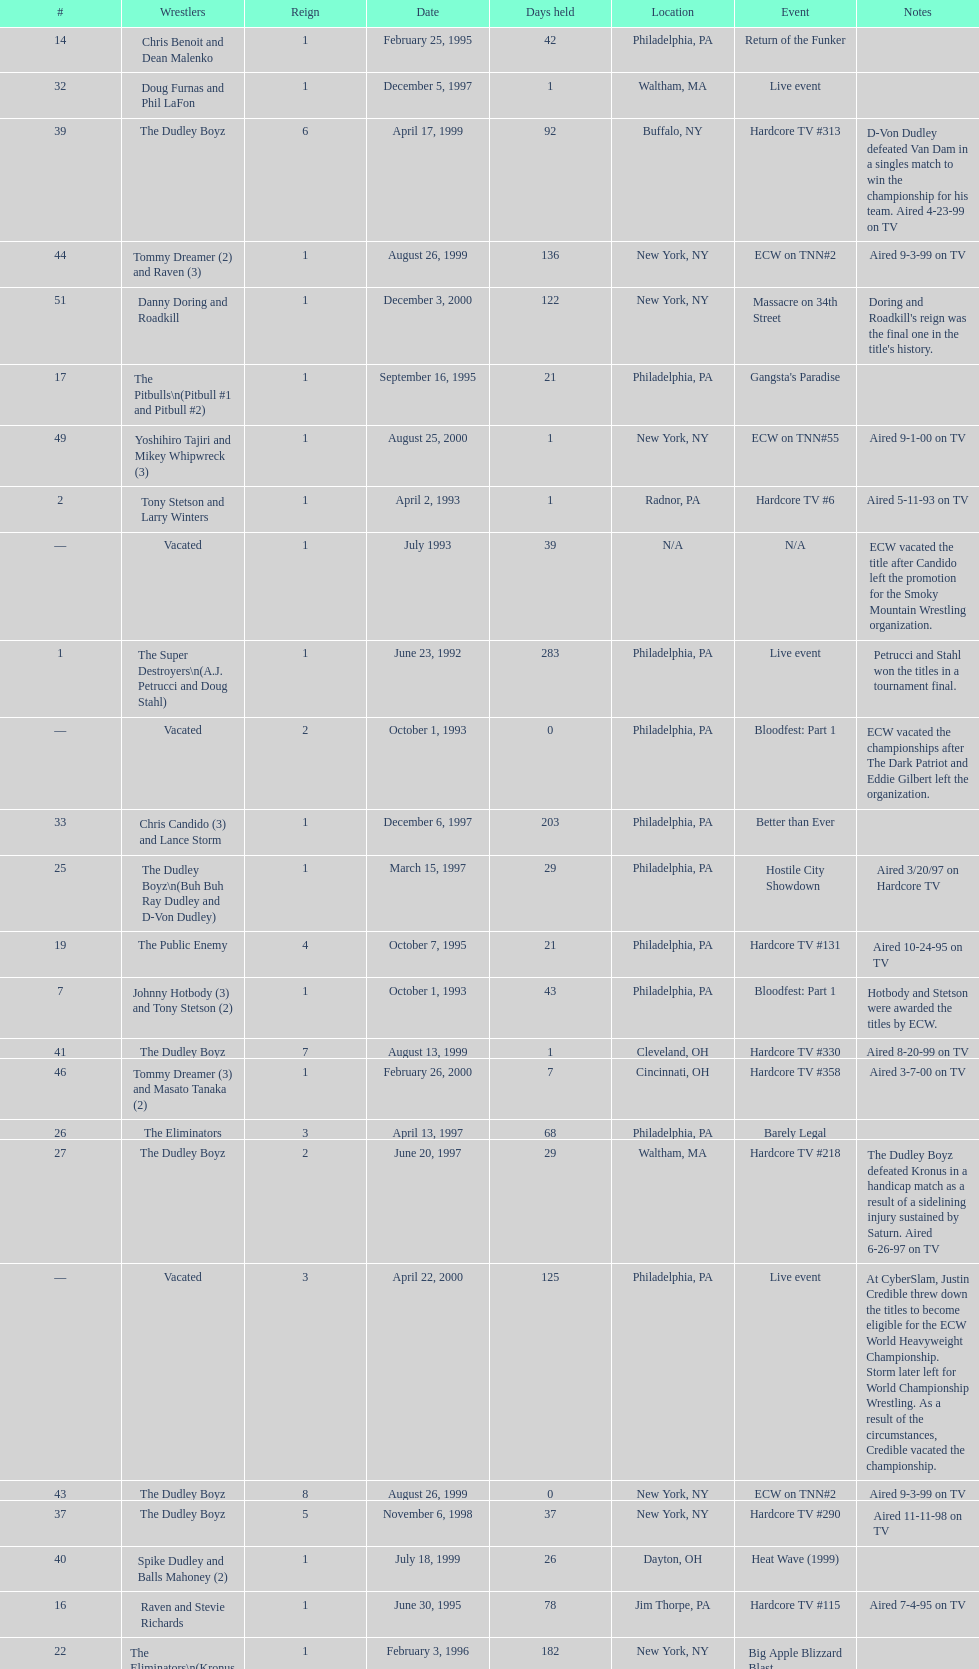What is the total days held on # 1st? 283. 